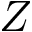<formula> <loc_0><loc_0><loc_500><loc_500>Z</formula> 